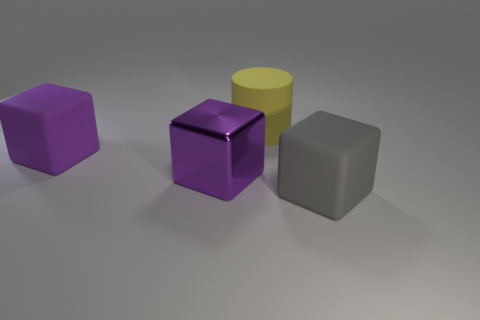Is the gray rubber block the same size as the purple matte block? yes 